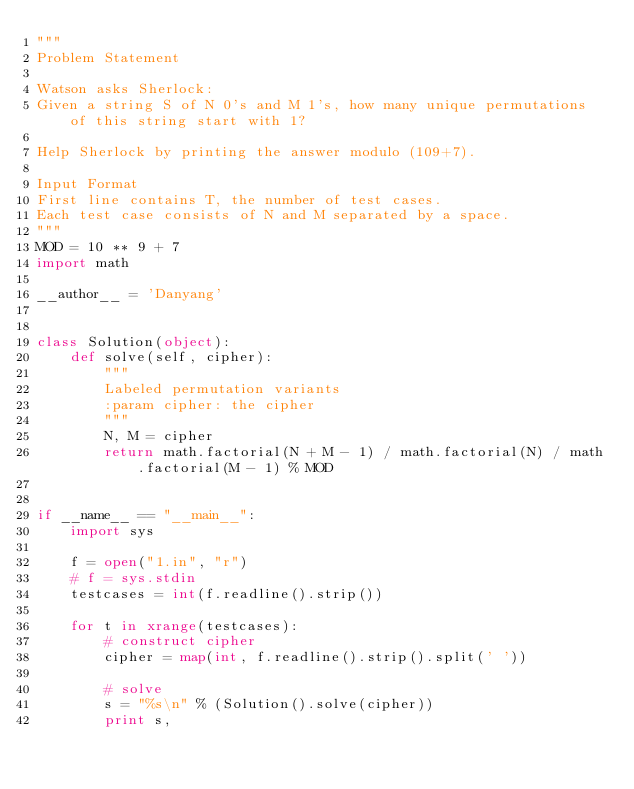Convert code to text. <code><loc_0><loc_0><loc_500><loc_500><_Python_>"""
Problem Statement

Watson asks Sherlock:
Given a string S of N 0's and M 1's, how many unique permutations of this string start with 1?

Help Sherlock by printing the answer modulo (109+7).

Input Format
First line contains T, the number of test cases.
Each test case consists of N and M separated by a space.
"""
MOD = 10 ** 9 + 7
import math

__author__ = 'Danyang'


class Solution(object):
    def solve(self, cipher):
        """
        Labeled permutation variants
        :param cipher: the cipher
        """
        N, M = cipher
        return math.factorial(N + M - 1) / math.factorial(N) / math.factorial(M - 1) % MOD


if __name__ == "__main__":
    import sys

    f = open("1.in", "r")
    # f = sys.stdin
    testcases = int(f.readline().strip())

    for t in xrange(testcases):
        # construct cipher
        cipher = map(int, f.readline().strip().split(' '))

        # solve
        s = "%s\n" % (Solution().solve(cipher))
        print s,
</code> 